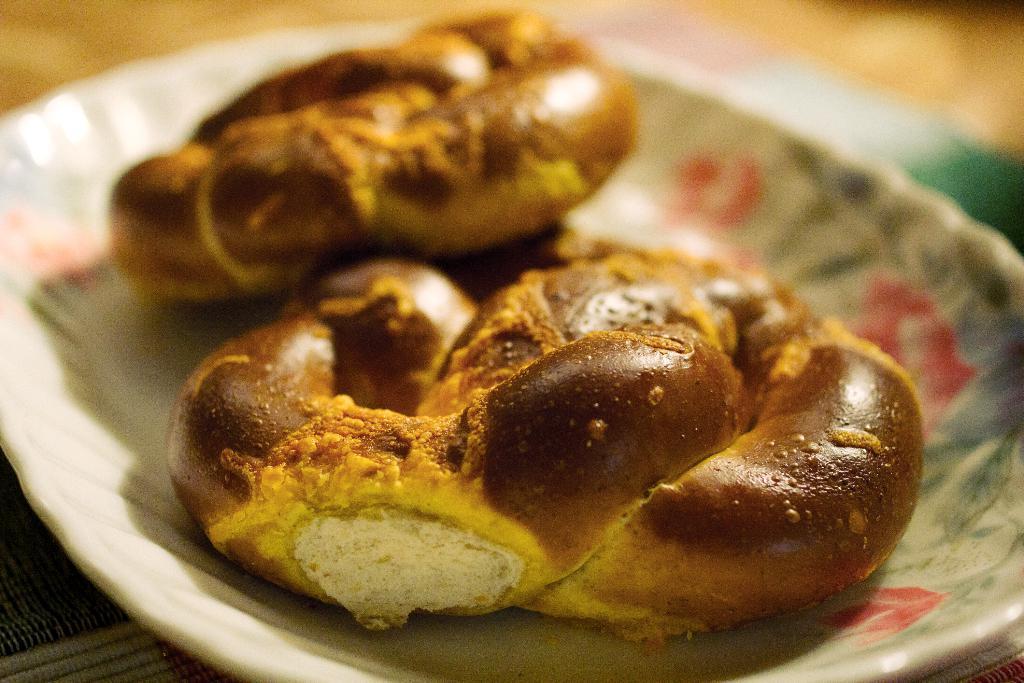In one or two sentences, can you explain what this image depicts? In this image we can see a plate containing food placed on the surface. 